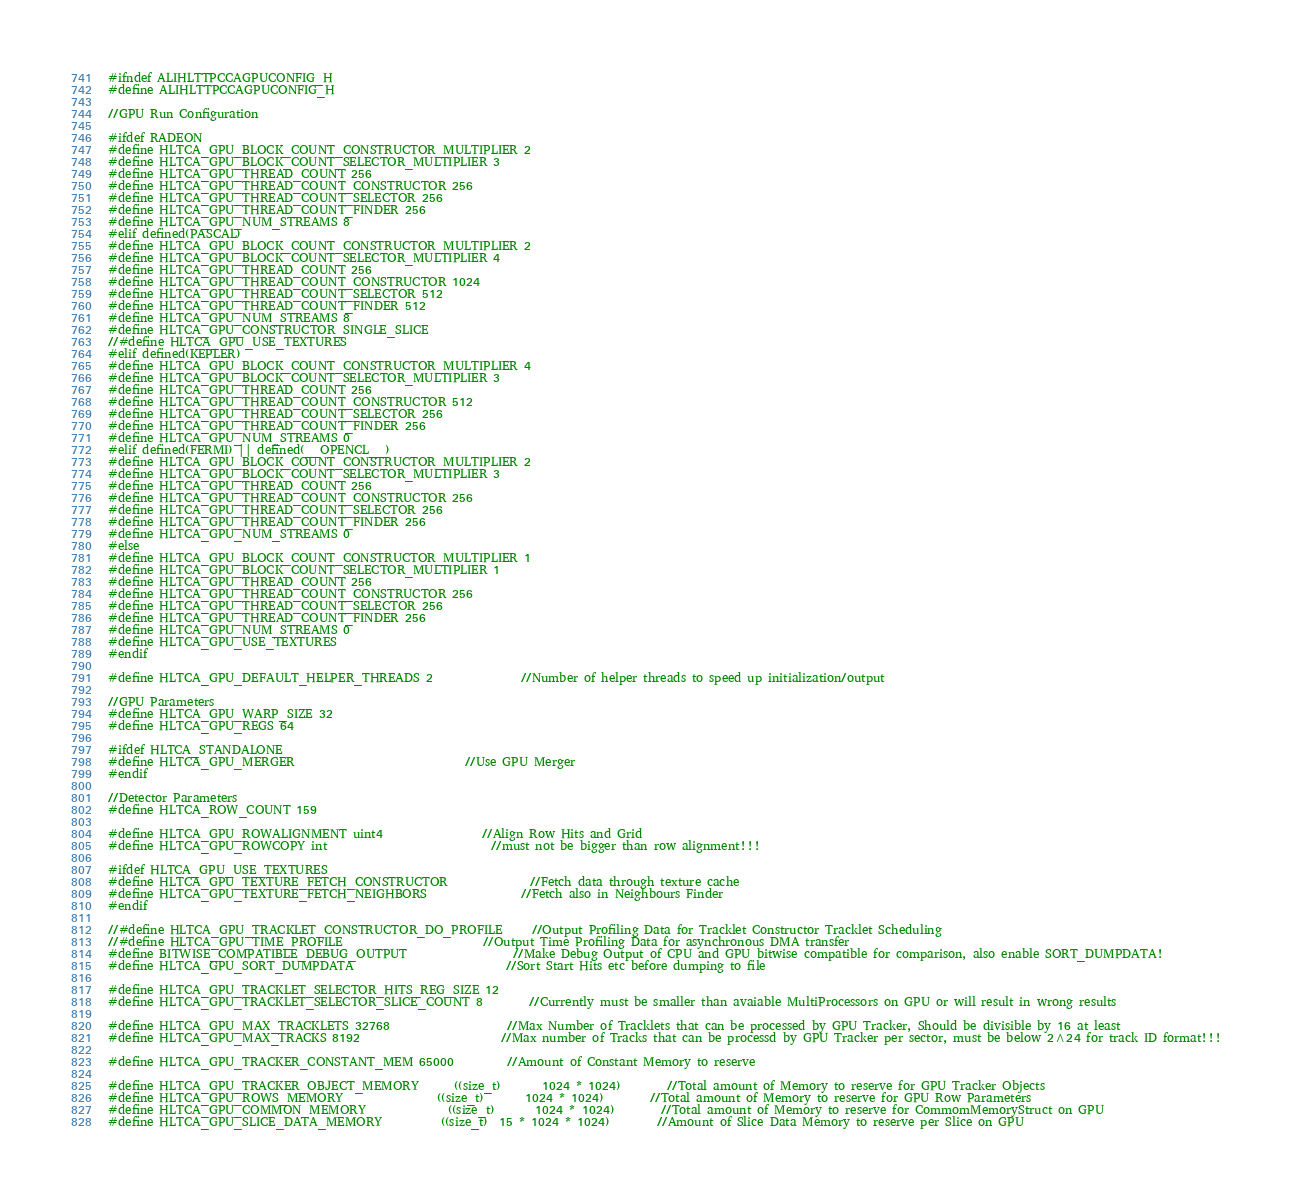Convert code to text. <code><loc_0><loc_0><loc_500><loc_500><_C_>#ifndef ALIHLTTPCCAGPUCONFIG_H
#define ALIHLTTPCCAGPUCONFIG_H

//GPU Run Configuration

#ifdef RADEON
#define HLTCA_GPU_BLOCK_COUNT_CONSTRUCTOR_MULTIPLIER 2
#define HLTCA_GPU_BLOCK_COUNT_SELECTOR_MULTIPLIER 3
#define HLTCA_GPU_THREAD_COUNT 256
#define HLTCA_GPU_THREAD_COUNT_CONSTRUCTOR 256
#define HLTCA_GPU_THREAD_COUNT_SELECTOR 256
#define HLTCA_GPU_THREAD_COUNT_FINDER 256
#define HLTCA_GPU_NUM_STREAMS 8
#elif defined(PASCAL)
#define HLTCA_GPU_BLOCK_COUNT_CONSTRUCTOR_MULTIPLIER 2
#define HLTCA_GPU_BLOCK_COUNT_SELECTOR_MULTIPLIER 4
#define HLTCA_GPU_THREAD_COUNT 256
#define HLTCA_GPU_THREAD_COUNT_CONSTRUCTOR 1024
#define HLTCA_GPU_THREAD_COUNT_SELECTOR 512
#define HLTCA_GPU_THREAD_COUNT_FINDER 512
#define HLTCA_GPU_NUM_STREAMS 8
#define HLTCA_GPU_CONSTRUCTOR_SINGLE_SLICE
//#define HLTCA_GPU_USE_TEXTURES
#elif defined(KEPLER)
#define HLTCA_GPU_BLOCK_COUNT_CONSTRUCTOR_MULTIPLIER 4
#define HLTCA_GPU_BLOCK_COUNT_SELECTOR_MULTIPLIER 3
#define HLTCA_GPU_THREAD_COUNT 256
#define HLTCA_GPU_THREAD_COUNT_CONSTRUCTOR 512
#define HLTCA_GPU_THREAD_COUNT_SELECTOR 256
#define HLTCA_GPU_THREAD_COUNT_FINDER 256
#define HLTCA_GPU_NUM_STREAMS 0
#elif defined(FERMI) || defined(__OPENCL__)
#define HLTCA_GPU_BLOCK_COUNT_CONSTRUCTOR_MULTIPLIER 2
#define HLTCA_GPU_BLOCK_COUNT_SELECTOR_MULTIPLIER 3
#define HLTCA_GPU_THREAD_COUNT 256
#define HLTCA_GPU_THREAD_COUNT_CONSTRUCTOR 256
#define HLTCA_GPU_THREAD_COUNT_SELECTOR 256
#define HLTCA_GPU_THREAD_COUNT_FINDER 256
#define HLTCA_GPU_NUM_STREAMS 0
#else
#define HLTCA_GPU_BLOCK_COUNT_CONSTRUCTOR_MULTIPLIER 1
#define HLTCA_GPU_BLOCK_COUNT_SELECTOR_MULTIPLIER 1
#define HLTCA_GPU_THREAD_COUNT 256
#define HLTCA_GPU_THREAD_COUNT_CONSTRUCTOR 256
#define HLTCA_GPU_THREAD_COUNT_SELECTOR 256
#define HLTCA_GPU_THREAD_COUNT_FINDER 256
#define HLTCA_GPU_NUM_STREAMS 0
#define HLTCA_GPU_USE_TEXTURES
#endif

#define HLTCA_GPU_DEFAULT_HELPER_THREADS 2				//Number of helper threads to speed up initialization/output

//GPU Parameters
#define HLTCA_GPU_WARP_SIZE 32
#define HLTCA_GPU_REGS 64

#ifdef HLTCA_STANDALONE
#define HLTCA_GPU_MERGER								//Use GPU Merger
#endif

//Detector Parameters
#define HLTCA_ROW_COUNT 159

#define HLTCA_GPU_ROWALIGNMENT uint4					//Align Row Hits and Grid
#define HLTCA_GPU_ROWCOPY int							//must not be bigger than row alignment!!!

#ifdef HLTCA_GPU_USE_TEXTURES
#define HLTCA_GPU_TEXTURE_FETCH_CONSTRUCTOR				//Fetch data through texture cache
#define HLTCA_GPU_TEXTURE_FETCH_NEIGHBORS				//Fetch also in Neighbours Finder
#endif

//#define HLTCA_GPU_TRACKLET_CONSTRUCTOR_DO_PROFILE		//Output Profiling Data for Tracklet Constructor Tracklet Scheduling
//#define HLTCA_GPU_TIME_PROFILE						//Output Time Profiling Data for asynchronous DMA transfer
#define BITWISE_COMPATIBLE_DEBUG_OUTPUT					//Make Debug Output of CPU and GPU bitwise compatible for comparison, also enable SORT_DUMPDATA!
#define HLTCA_GPU_SORT_DUMPDATA							//Sort Start Hits etc before dumping to file

#define HLTCA_GPU_TRACKLET_SELECTOR_HITS_REG_SIZE 12
#define HLTCA_GPU_TRACKLET_SELECTOR_SLICE_COUNT 8		//Currently must be smaller than avaiable MultiProcessors on GPU or will result in wrong results

#define HLTCA_GPU_MAX_TRACKLETS 32768					//Max Number of Tracklets that can be processed by GPU Tracker, Should be divisible by 16 at least
#define HLTCA_GPU_MAX_TRACKS 8192						//Max number of Tracks that can be processd by GPU Tracker per sector, must be below 2^24 for track ID format!!!

#define HLTCA_GPU_TRACKER_CONSTANT_MEM 65000			//Amount of Constant Memory to reserve

#define HLTCA_GPU_TRACKER_OBJECT_MEMORY		((size_t)       1024 * 1024)		//Total amount of Memory to reserve for GPU Tracker Objects
#define HLTCA_GPU_ROWS_MEMORY				((size_t)       1024 * 1024)		//Total amount of Memory to reserve for GPU Row Parameters
#define HLTCA_GPU_COMMON_MEMORY				((size_t)       1024 * 1024)		//Total amount of Memory to reserve for CommomMemoryStruct on GPU
#define HLTCA_GPU_SLICE_DATA_MEMORY			((size_t)  15 * 1024 * 1024)		//Amount of Slice Data Memory to reserve per Slice on GPU</code> 